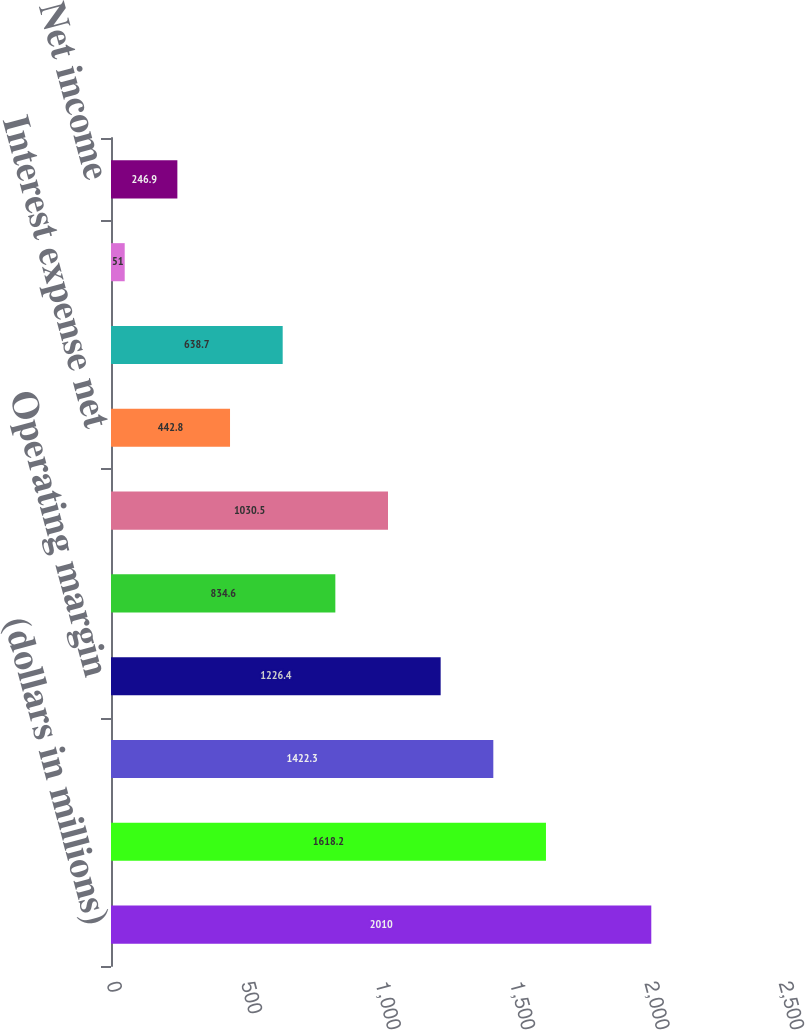<chart> <loc_0><loc_0><loc_500><loc_500><bar_chart><fcel>(dollars in millions)<fcel>Total revenues<fcel>Cost of sales<fcel>Operating margin<fcel>General and administrative<fcel>Income from operations<fcel>Interest expense net<fcel>Income before provision for<fcel>Provision for income taxes<fcel>Net income<nl><fcel>2010<fcel>1618.2<fcel>1422.3<fcel>1226.4<fcel>834.6<fcel>1030.5<fcel>442.8<fcel>638.7<fcel>51<fcel>246.9<nl></chart> 